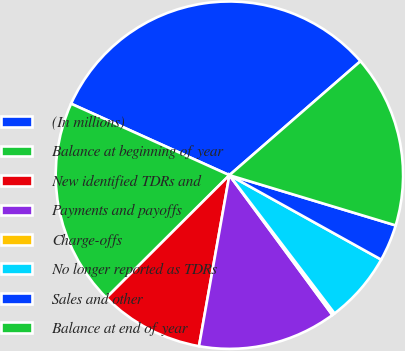Convert chart. <chart><loc_0><loc_0><loc_500><loc_500><pie_chart><fcel>(In millions)<fcel>Balance at beginning of year<fcel>New identified TDRs and<fcel>Payments and payoffs<fcel>Charge-offs<fcel>No longer reported as TDRs<fcel>Sales and other<fcel>Balance at end of year<nl><fcel>31.86%<fcel>19.22%<fcel>9.73%<fcel>12.9%<fcel>0.25%<fcel>6.57%<fcel>3.41%<fcel>16.06%<nl></chart> 